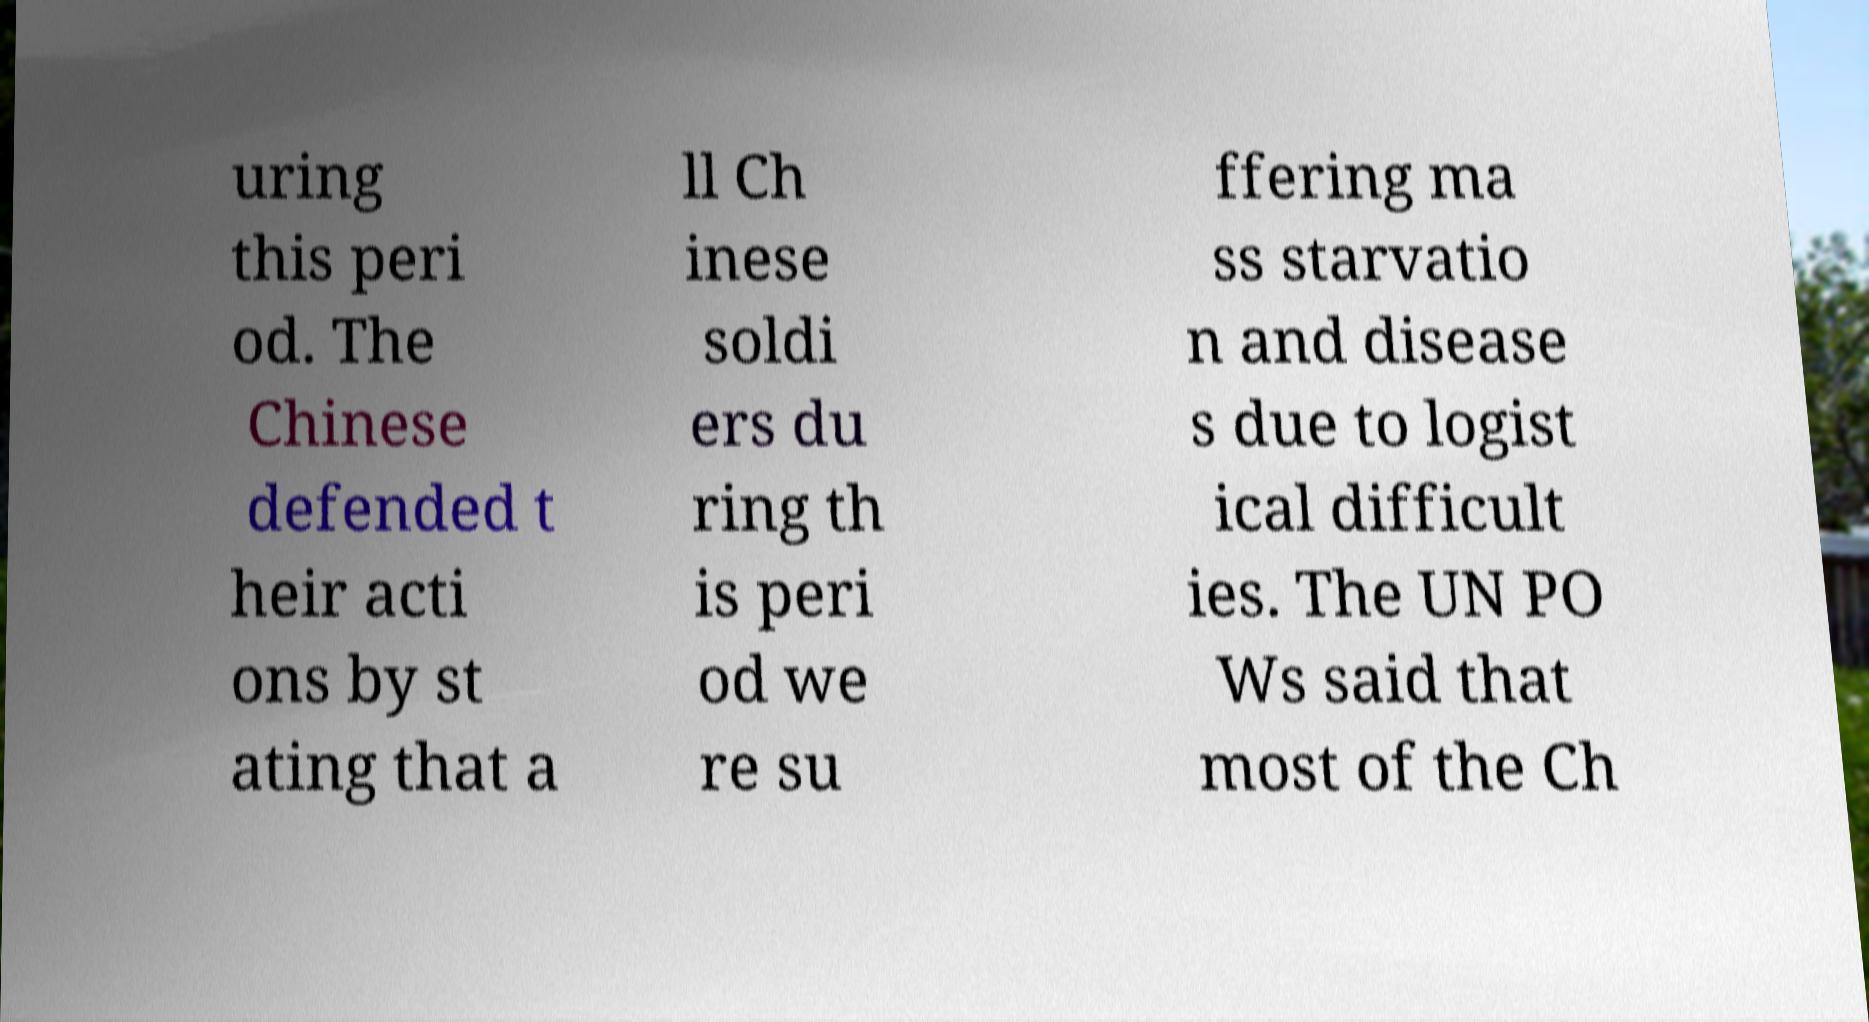Can you read and provide the text displayed in the image?This photo seems to have some interesting text. Can you extract and type it out for me? uring this peri od. The Chinese defended t heir acti ons by st ating that a ll Ch inese soldi ers du ring th is peri od we re su ffering ma ss starvatio n and disease s due to logist ical difficult ies. The UN PO Ws said that most of the Ch 